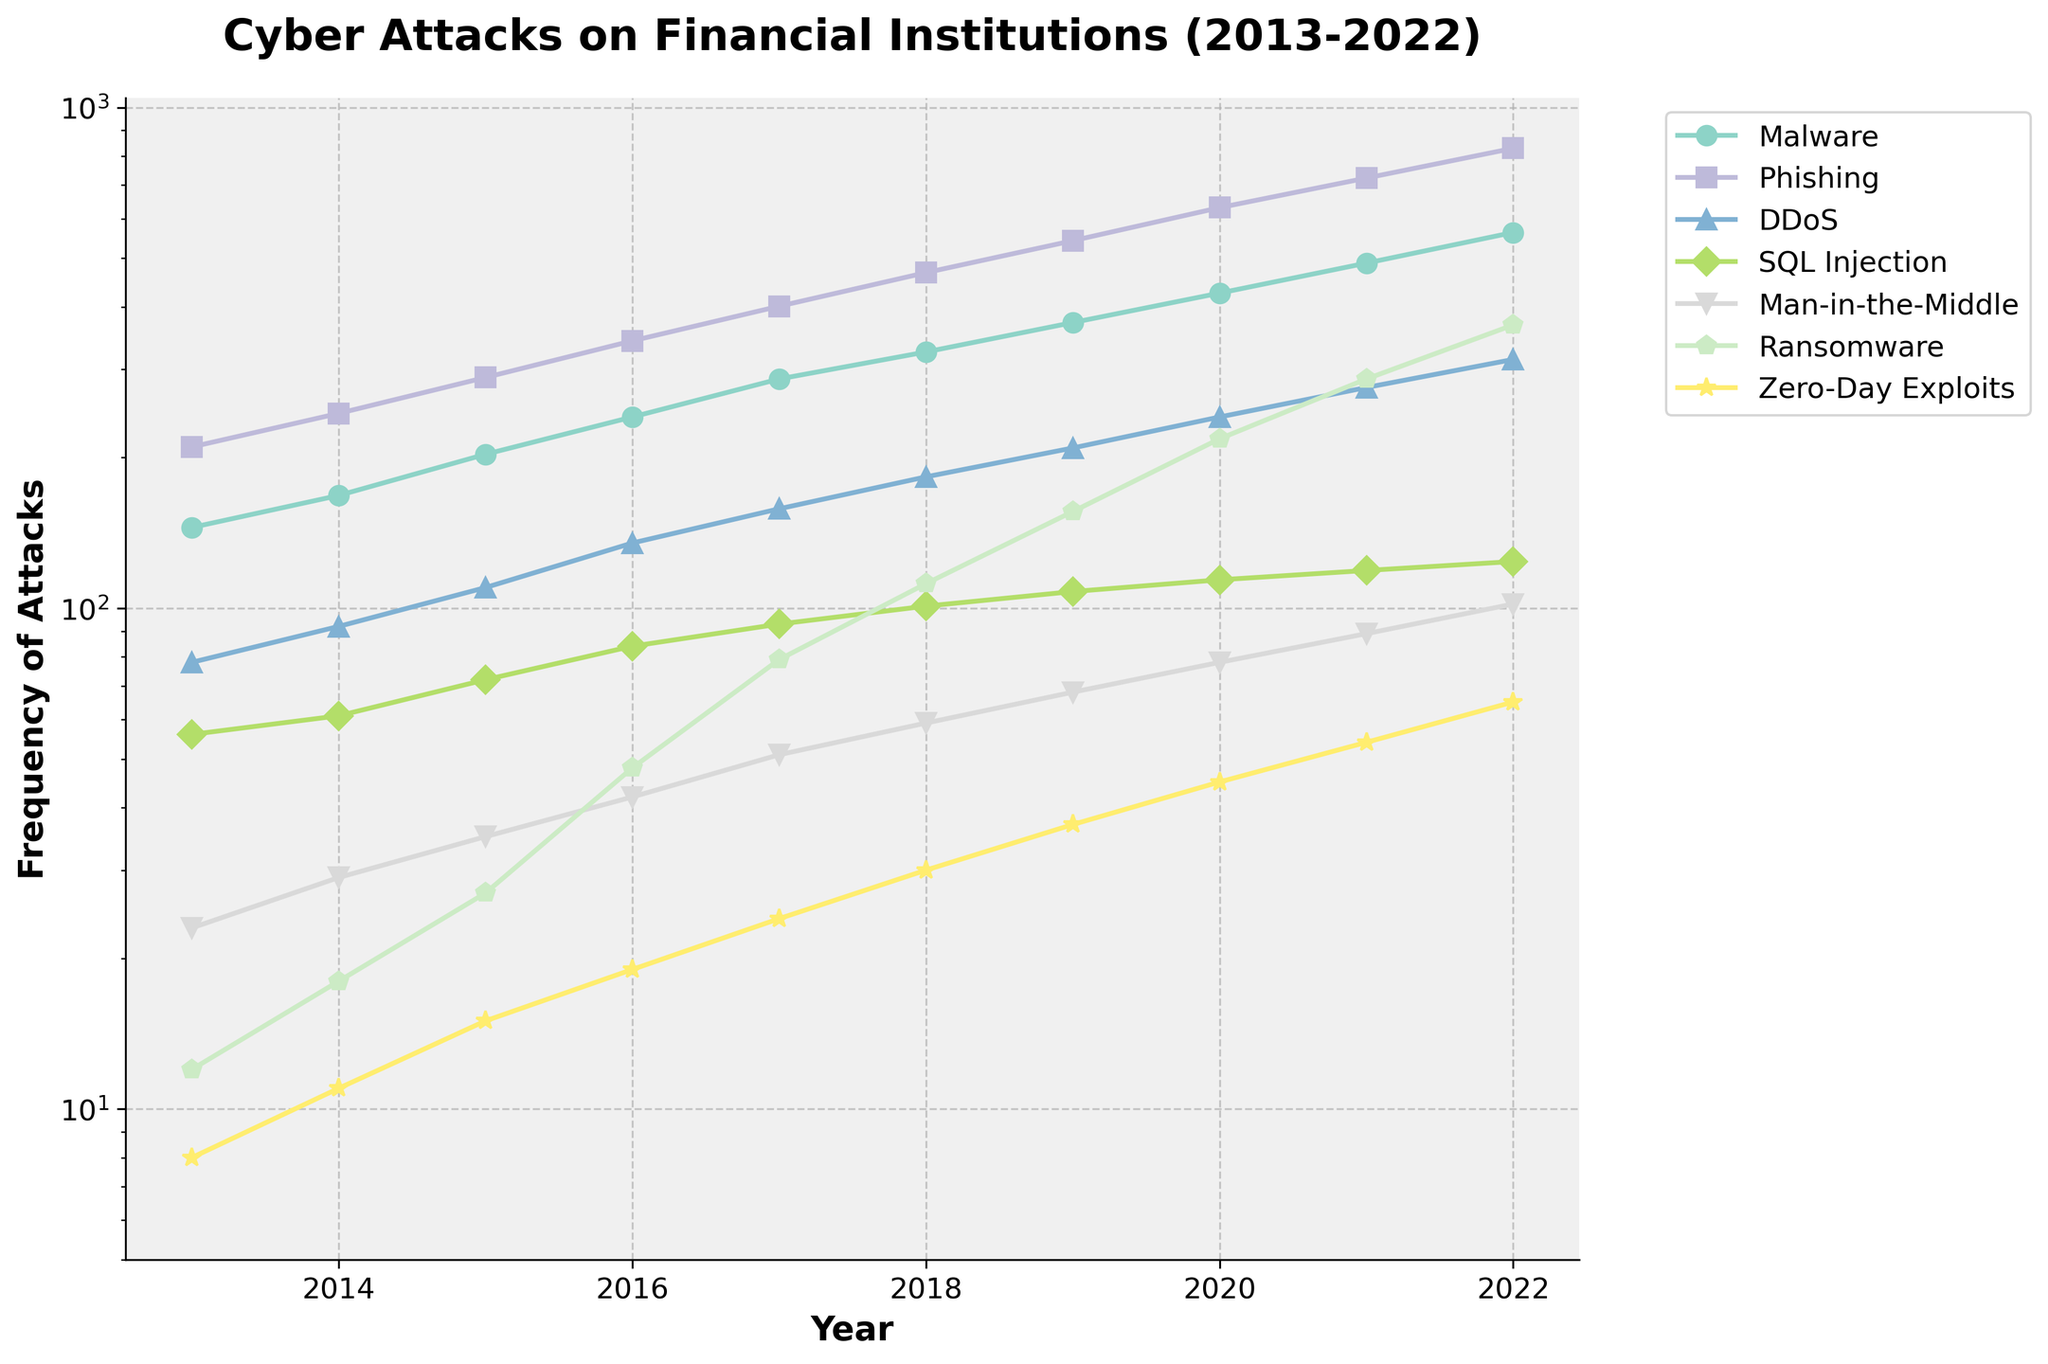What is the most frequent type of cyber attack in 2022? The line representing each type of attack shows the frequency of that attack. The highest point in 2022 corresponds to Phishing, with a frequency of 829.
Answer: Phishing Which type of attack had the smallest increase in frequency from 2013 to 2022? By comparing the increase for each type, we see that Man-in-the-Middle attacks increased from 23 to 102, which is an increase of 79. No other attack type increases by less than this amount.
Answer: Man-in-the-Middle Which attack type had approximately its frequency value doubled from 2016 to 2019? From the line chart, Malware had a frequency of 241 in 2016 and 372 in 2019, which is not exactly but approximately a doubling from 2016 to 2019.
Answer: Malware What is the total frequency of Zero-Day Exploits attacks across the entire decade? Summing up the frequencies from 2013 to 2022: 8 + 11 + 15 + 19 + 24 + 30 + 37 + 45 + 54 + 65 = 308.
Answer: 308 Which attack type shows the steepest increase in frequency between 2020 and 2021? By observing the slope of each line segment between 2020 and 2021, Ransomware has the steepest incline, going from 218 to 287.
Answer: Ransomware In which year did the frequency of DDoS attacks surpass 200? By tracing the DDoS line, it is clear that it surpassed 200 in 2019 with a frequency of 209.
Answer: 2019 By how much did the frequency of SQL Injection attacks change from 2015 to 2022? The frequency in 2015 was 72 and it increased to 124 in 2022. The change is 124 - 72 = 52.
Answer: 52 Which type of attack had a frequency of less than 50 in 2016 but more than 100 in 2021? Observing the plot, Ransomware was below 50 in 2016 (48) and above 100 in 2021 (287).
Answer: Ransomware 